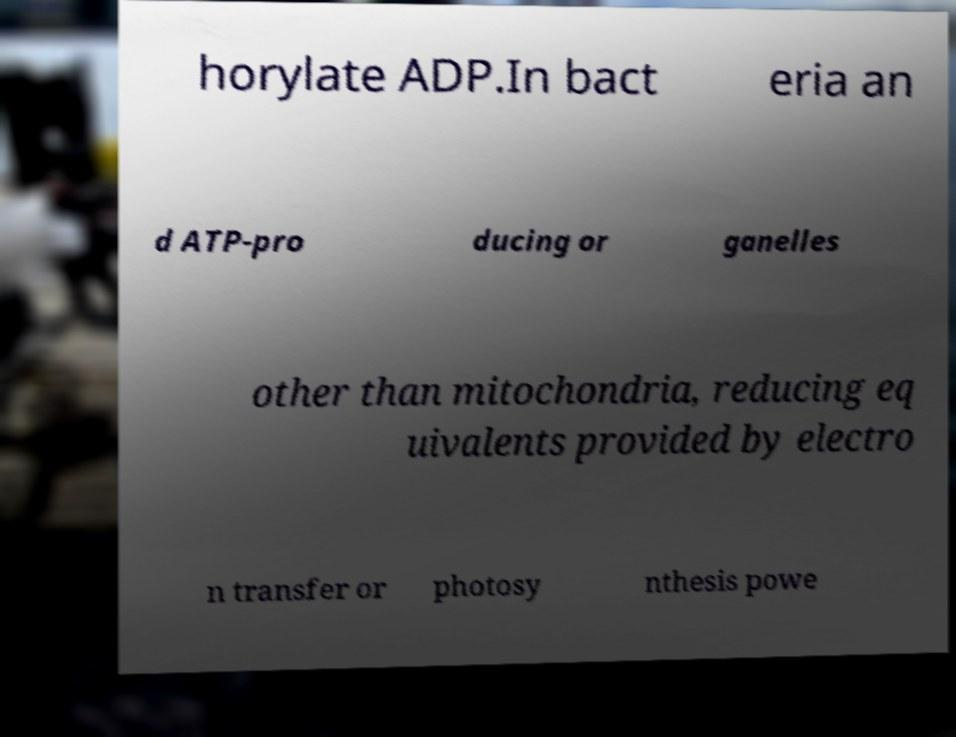I need the written content from this picture converted into text. Can you do that? horylate ADP.In bact eria an d ATP-pro ducing or ganelles other than mitochondria, reducing eq uivalents provided by electro n transfer or photosy nthesis powe 